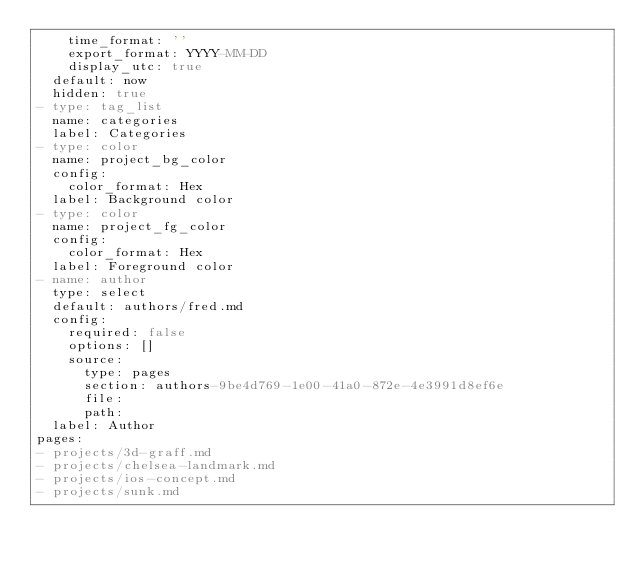Convert code to text. <code><loc_0><loc_0><loc_500><loc_500><_YAML_>    time_format: ''
    export_format: YYYY-MM-DD
    display_utc: true
  default: now
  hidden: true
- type: tag_list
  name: categories
  label: Categories
- type: color
  name: project_bg_color
  config:
    color_format: Hex
  label: Background color
- type: color
  name: project_fg_color
  config:
    color_format: Hex
  label: Foreground color
- name: author
  type: select
  default: authors/fred.md
  config:
    required: false
    options: []
    source:
      type: pages
      section: authors-9be4d769-1e00-41a0-872e-4e3991d8ef6e
      file: 
      path: 
  label: Author
pages:
- projects/3d-graff.md
- projects/chelsea-landmark.md
- projects/ios-concept.md
- projects/sunk.md
</code> 